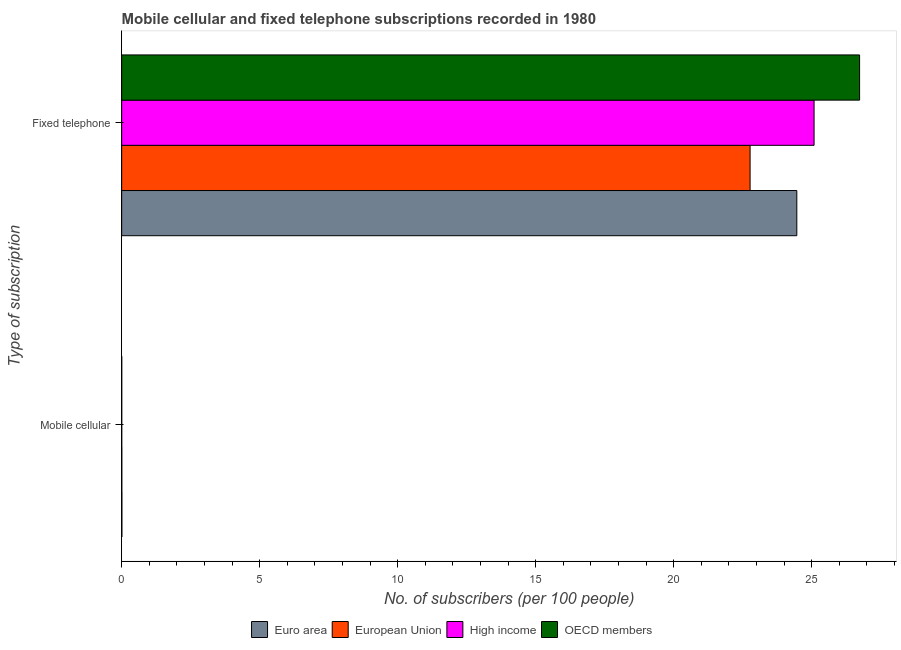How many different coloured bars are there?
Keep it short and to the point. 4. How many groups of bars are there?
Provide a succinct answer. 2. How many bars are there on the 2nd tick from the top?
Your answer should be very brief. 4. What is the label of the 2nd group of bars from the top?
Your response must be concise. Mobile cellular. What is the number of mobile cellular subscribers in OECD members?
Provide a succinct answer. 0. Across all countries, what is the maximum number of fixed telephone subscribers?
Give a very brief answer. 26.73. Across all countries, what is the minimum number of fixed telephone subscribers?
Keep it short and to the point. 22.77. What is the total number of fixed telephone subscribers in the graph?
Offer a very short reply. 99.04. What is the difference between the number of mobile cellular subscribers in OECD members and that in High income?
Your answer should be compact. 0. What is the difference between the number of fixed telephone subscribers in Euro area and the number of mobile cellular subscribers in OECD members?
Offer a terse response. 24.46. What is the average number of fixed telephone subscribers per country?
Make the answer very short. 24.76. What is the difference between the number of mobile cellular subscribers and number of fixed telephone subscribers in High income?
Ensure brevity in your answer.  -25.08. What is the ratio of the number of mobile cellular subscribers in Euro area to that in High income?
Make the answer very short. 3.65. Is the number of fixed telephone subscribers in OECD members less than that in European Union?
Offer a terse response. No. How many bars are there?
Keep it short and to the point. 8. Are the values on the major ticks of X-axis written in scientific E-notation?
Offer a terse response. No. What is the title of the graph?
Provide a succinct answer. Mobile cellular and fixed telephone subscriptions recorded in 1980. Does "Iraq" appear as one of the legend labels in the graph?
Offer a very short reply. No. What is the label or title of the X-axis?
Your answer should be compact. No. of subscribers (per 100 people). What is the label or title of the Y-axis?
Make the answer very short. Type of subscription. What is the No. of subscribers (per 100 people) in Euro area in Mobile cellular?
Your answer should be compact. 0.01. What is the No. of subscribers (per 100 people) in European Union in Mobile cellular?
Your answer should be compact. 0.01. What is the No. of subscribers (per 100 people) of High income in Mobile cellular?
Offer a terse response. 0. What is the No. of subscribers (per 100 people) in OECD members in Mobile cellular?
Provide a succinct answer. 0. What is the No. of subscribers (per 100 people) in Euro area in Fixed telephone?
Your response must be concise. 24.46. What is the No. of subscribers (per 100 people) of European Union in Fixed telephone?
Your response must be concise. 22.77. What is the No. of subscribers (per 100 people) in High income in Fixed telephone?
Give a very brief answer. 25.08. What is the No. of subscribers (per 100 people) of OECD members in Fixed telephone?
Make the answer very short. 26.73. Across all Type of subscription, what is the maximum No. of subscribers (per 100 people) of Euro area?
Your response must be concise. 24.46. Across all Type of subscription, what is the maximum No. of subscribers (per 100 people) of European Union?
Your answer should be very brief. 22.77. Across all Type of subscription, what is the maximum No. of subscribers (per 100 people) of High income?
Make the answer very short. 25.08. Across all Type of subscription, what is the maximum No. of subscribers (per 100 people) of OECD members?
Make the answer very short. 26.73. Across all Type of subscription, what is the minimum No. of subscribers (per 100 people) of Euro area?
Keep it short and to the point. 0.01. Across all Type of subscription, what is the minimum No. of subscribers (per 100 people) of European Union?
Your answer should be compact. 0.01. Across all Type of subscription, what is the minimum No. of subscribers (per 100 people) in High income?
Your answer should be compact. 0. Across all Type of subscription, what is the minimum No. of subscribers (per 100 people) in OECD members?
Your response must be concise. 0. What is the total No. of subscribers (per 100 people) of Euro area in the graph?
Your answer should be compact. 24.47. What is the total No. of subscribers (per 100 people) of European Union in the graph?
Provide a succinct answer. 22.77. What is the total No. of subscribers (per 100 people) of High income in the graph?
Give a very brief answer. 25.09. What is the total No. of subscribers (per 100 people) of OECD members in the graph?
Give a very brief answer. 26.74. What is the difference between the No. of subscribers (per 100 people) in Euro area in Mobile cellular and that in Fixed telephone?
Your response must be concise. -24.45. What is the difference between the No. of subscribers (per 100 people) of European Union in Mobile cellular and that in Fixed telephone?
Your answer should be very brief. -22.76. What is the difference between the No. of subscribers (per 100 people) of High income in Mobile cellular and that in Fixed telephone?
Offer a very short reply. -25.08. What is the difference between the No. of subscribers (per 100 people) of OECD members in Mobile cellular and that in Fixed telephone?
Provide a short and direct response. -26.73. What is the difference between the No. of subscribers (per 100 people) in Euro area in Mobile cellular and the No. of subscribers (per 100 people) in European Union in Fixed telephone?
Provide a short and direct response. -22.76. What is the difference between the No. of subscribers (per 100 people) in Euro area in Mobile cellular and the No. of subscribers (per 100 people) in High income in Fixed telephone?
Keep it short and to the point. -25.08. What is the difference between the No. of subscribers (per 100 people) in Euro area in Mobile cellular and the No. of subscribers (per 100 people) in OECD members in Fixed telephone?
Your response must be concise. -26.73. What is the difference between the No. of subscribers (per 100 people) of European Union in Mobile cellular and the No. of subscribers (per 100 people) of High income in Fixed telephone?
Keep it short and to the point. -25.08. What is the difference between the No. of subscribers (per 100 people) of European Union in Mobile cellular and the No. of subscribers (per 100 people) of OECD members in Fixed telephone?
Provide a short and direct response. -26.73. What is the difference between the No. of subscribers (per 100 people) of High income in Mobile cellular and the No. of subscribers (per 100 people) of OECD members in Fixed telephone?
Offer a very short reply. -26.73. What is the average No. of subscribers (per 100 people) in Euro area per Type of subscription?
Provide a short and direct response. 12.23. What is the average No. of subscribers (per 100 people) of European Union per Type of subscription?
Provide a succinct answer. 11.39. What is the average No. of subscribers (per 100 people) in High income per Type of subscription?
Give a very brief answer. 12.54. What is the average No. of subscribers (per 100 people) in OECD members per Type of subscription?
Give a very brief answer. 13.37. What is the difference between the No. of subscribers (per 100 people) of Euro area and No. of subscribers (per 100 people) of European Union in Mobile cellular?
Offer a terse response. 0. What is the difference between the No. of subscribers (per 100 people) in Euro area and No. of subscribers (per 100 people) in High income in Mobile cellular?
Your answer should be very brief. 0.01. What is the difference between the No. of subscribers (per 100 people) in Euro area and No. of subscribers (per 100 people) in OECD members in Mobile cellular?
Ensure brevity in your answer.  0.01. What is the difference between the No. of subscribers (per 100 people) in European Union and No. of subscribers (per 100 people) in High income in Mobile cellular?
Your response must be concise. 0. What is the difference between the No. of subscribers (per 100 people) of European Union and No. of subscribers (per 100 people) of OECD members in Mobile cellular?
Make the answer very short. 0. What is the difference between the No. of subscribers (per 100 people) in High income and No. of subscribers (per 100 people) in OECD members in Mobile cellular?
Your answer should be compact. -0. What is the difference between the No. of subscribers (per 100 people) in Euro area and No. of subscribers (per 100 people) in European Union in Fixed telephone?
Your answer should be compact. 1.69. What is the difference between the No. of subscribers (per 100 people) in Euro area and No. of subscribers (per 100 people) in High income in Fixed telephone?
Your answer should be very brief. -0.63. What is the difference between the No. of subscribers (per 100 people) of Euro area and No. of subscribers (per 100 people) of OECD members in Fixed telephone?
Make the answer very short. -2.27. What is the difference between the No. of subscribers (per 100 people) in European Union and No. of subscribers (per 100 people) in High income in Fixed telephone?
Your response must be concise. -2.32. What is the difference between the No. of subscribers (per 100 people) in European Union and No. of subscribers (per 100 people) in OECD members in Fixed telephone?
Ensure brevity in your answer.  -3.97. What is the difference between the No. of subscribers (per 100 people) in High income and No. of subscribers (per 100 people) in OECD members in Fixed telephone?
Ensure brevity in your answer.  -1.65. What is the ratio of the No. of subscribers (per 100 people) of European Union in Mobile cellular to that in Fixed telephone?
Your answer should be very brief. 0. What is the ratio of the No. of subscribers (per 100 people) in OECD members in Mobile cellular to that in Fixed telephone?
Your response must be concise. 0. What is the difference between the highest and the second highest No. of subscribers (per 100 people) of Euro area?
Give a very brief answer. 24.45. What is the difference between the highest and the second highest No. of subscribers (per 100 people) of European Union?
Keep it short and to the point. 22.76. What is the difference between the highest and the second highest No. of subscribers (per 100 people) of High income?
Your response must be concise. 25.08. What is the difference between the highest and the second highest No. of subscribers (per 100 people) in OECD members?
Your response must be concise. 26.73. What is the difference between the highest and the lowest No. of subscribers (per 100 people) in Euro area?
Give a very brief answer. 24.45. What is the difference between the highest and the lowest No. of subscribers (per 100 people) in European Union?
Offer a terse response. 22.76. What is the difference between the highest and the lowest No. of subscribers (per 100 people) of High income?
Offer a very short reply. 25.08. What is the difference between the highest and the lowest No. of subscribers (per 100 people) of OECD members?
Provide a succinct answer. 26.73. 